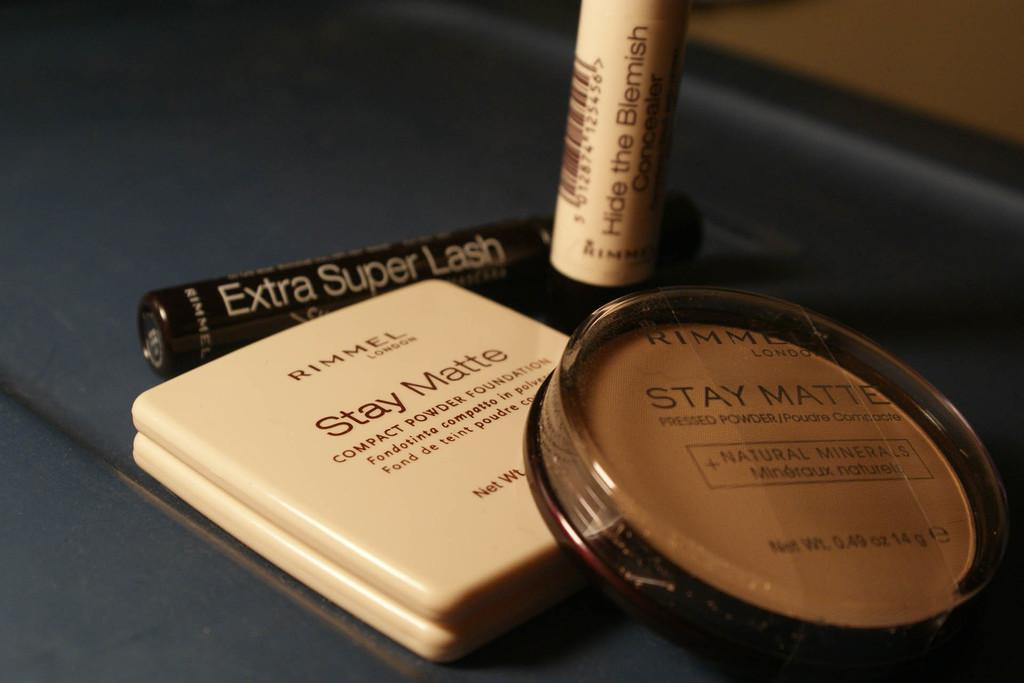<image>
Provide a brief description of the given image. Some make up items with Stay Matte written on them 